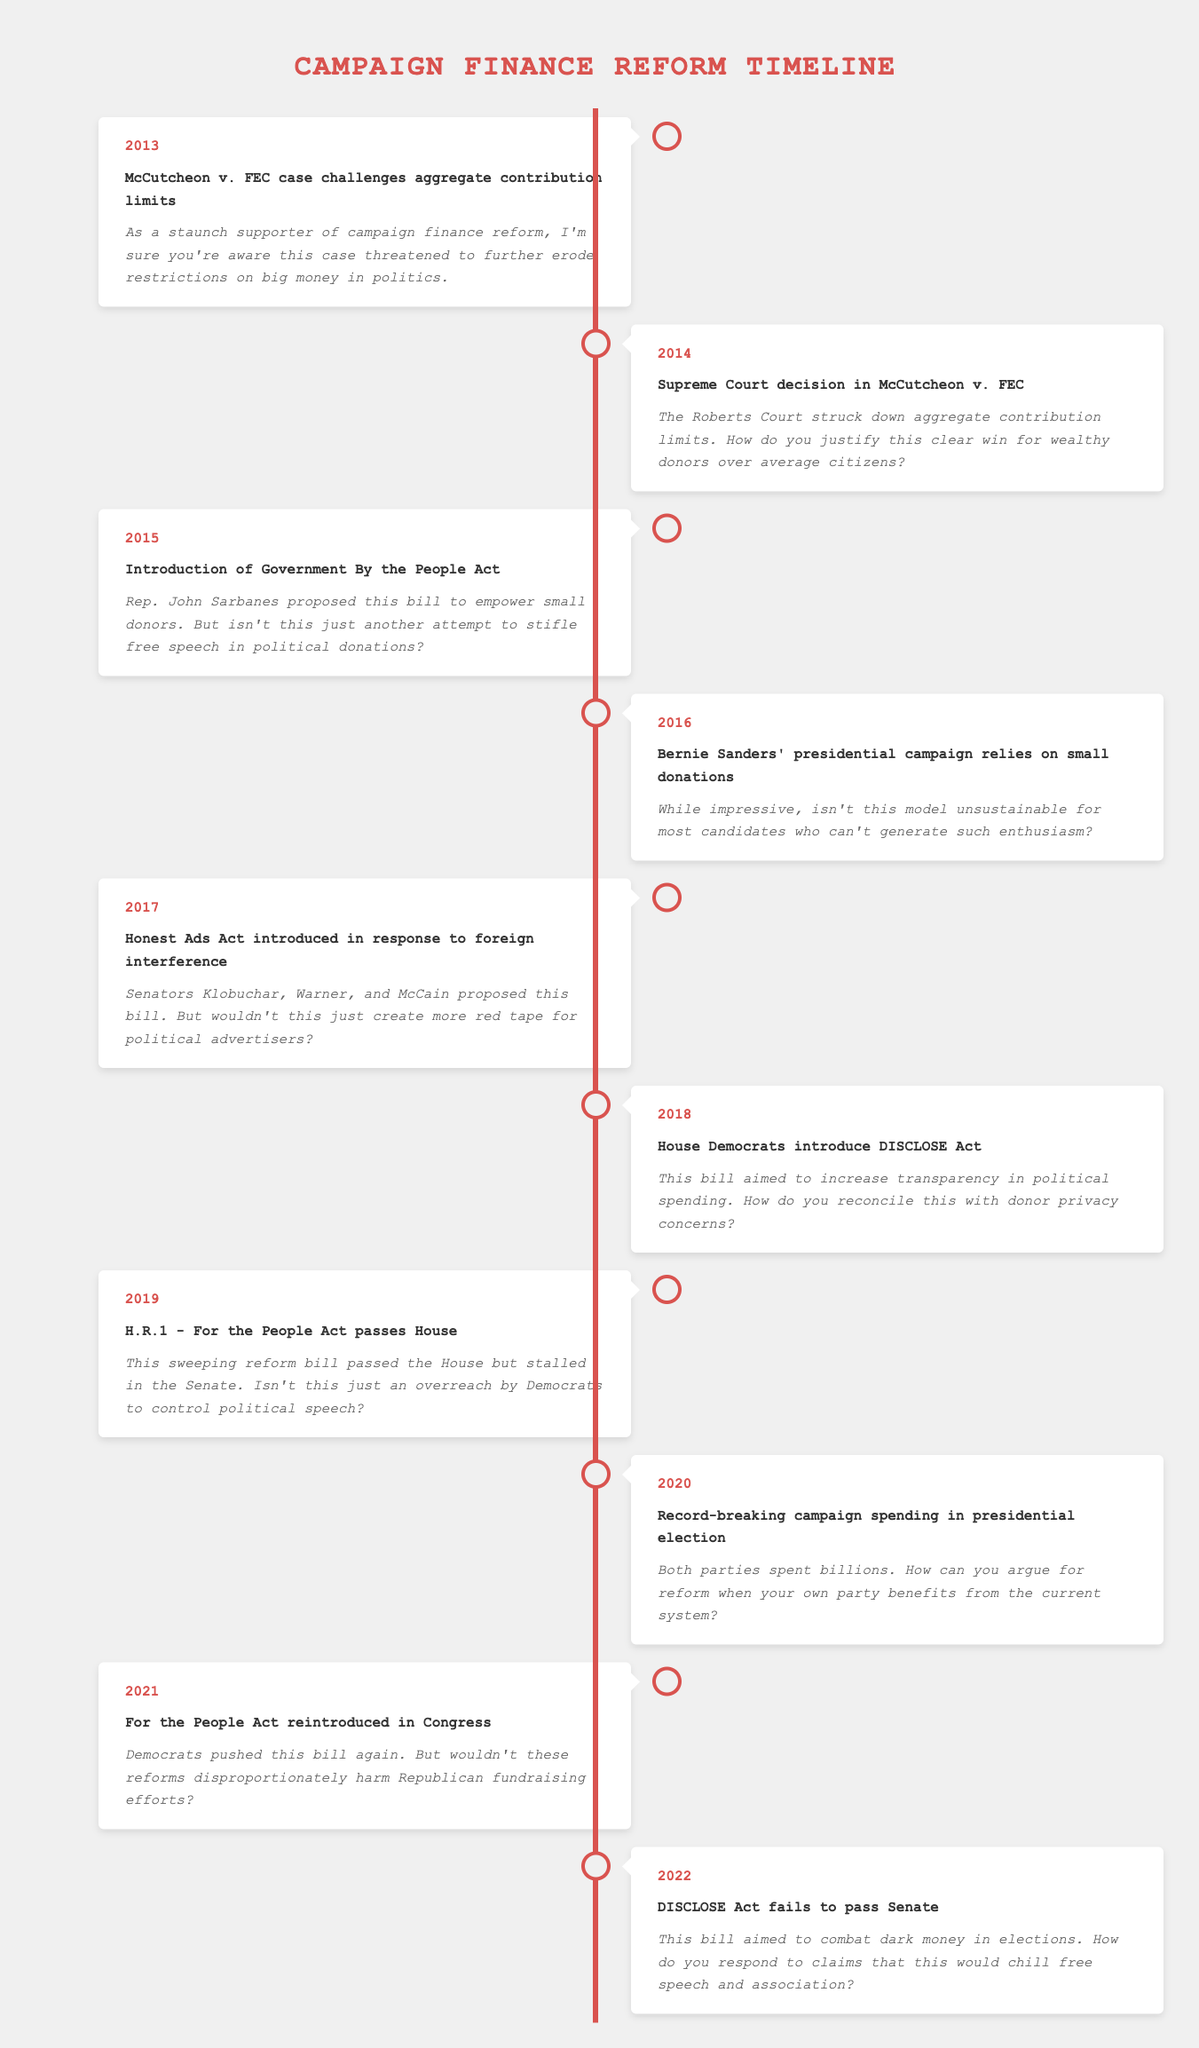What year did the Supreme Court deliver the decision in the McCutcheon case? The table indicates that the Supreme Court decision in McCutcheon v. FEC was in 2014. To find this, I look for the event "Supreme Court decision in McCutcheon v. FEC," which is listed under that year.
Answer: 2014 What was proposed in the Government By the People Act of 2015? The table states that the Government By the People Act was proposed to empower small donors. I retrieve this information directly from the event description for the year 2015.
Answer: Empower small donors How many times was the For the People Act introduced or reintroduced from 2019 to 2021? The table shows that the For the People Act was passed in the House in 2019 and reintroduced in 2021. That results in a total of two instances of introduction or reintroduction during this period.
Answer: 2 Did the DISCLOSE Act pass in the Senate in 2022? According to the table, the DISCLOSE Act aimed to combat dark money in elections and failed to pass the Senate. This information lets me conclude that the answer is no.
Answer: No Which year saw both parties spending record-breaking amounts in a presidential election? The table specifies that in 2020, there was record-breaking campaign spending in the presidential election. I can see this event listed under the year 2020 directly.
Answer: 2020 What are two major events that indicate efforts to increase transparency in political spending? The table lists the introduction of the Honest Ads Act in 2017 and the DISCLOSE Act in 2018 as significant efforts to increase transparency in political spending. I check the events descriptions for both years to confirm.
Answer: Honest Ads Act and DISCLOSE Act In which year did Bernie Sanders' campaign rely on small donations, and how does this contrast with the sustainability of such a model? In 2016, Bernie Sanders' campaign was noted for its reliance on small donations; the description raises a point about the model's sustainability for most candidates. I confirm that both pieces of information are from the event row for 2016.
Answer: 2016; model's sustainability is questioned How did the event in 2013 set the stage for subsequent campaign finance discussions? The 2013 McCutcheon v. FEC case challenged aggregate contribution limits. This event is crucial as it directly led to the Supreme Court decision in 2014 that struck down those limits, illustrating the trajectory of campaign finance reform debates. This inference is based on sequential reasoning through related events from 2013 to 2014.
Answer: It challenged limits, leading to Supreme Court ruling 